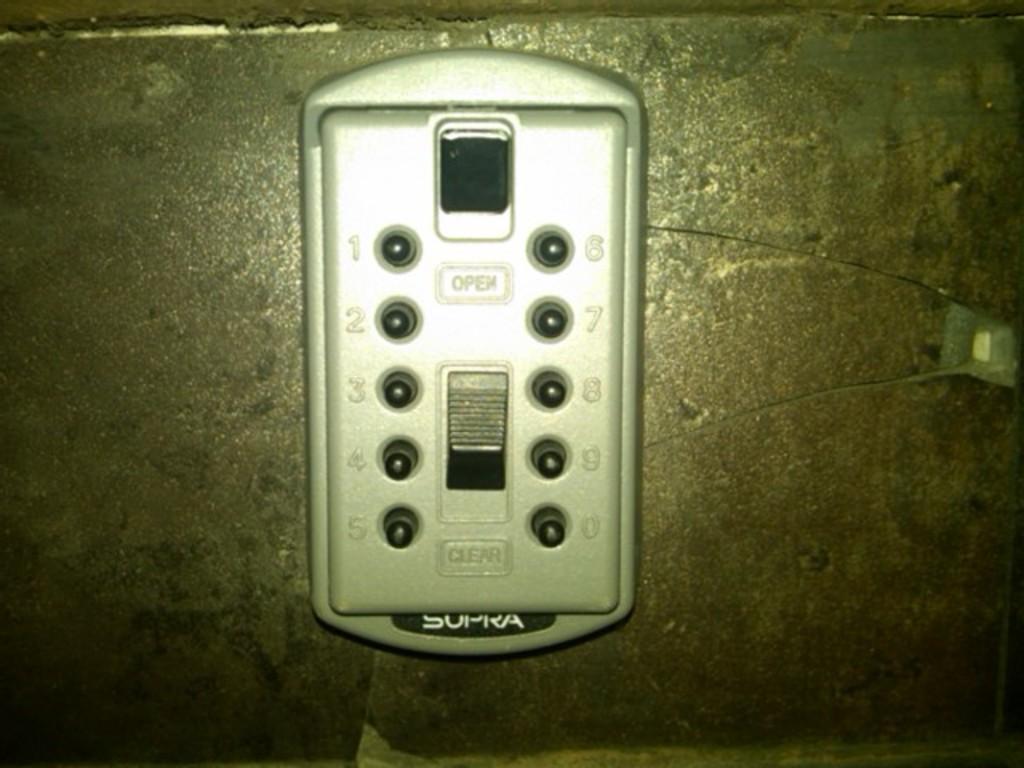What's the first number on the right side of the panel?
Your answer should be very brief. 6. 